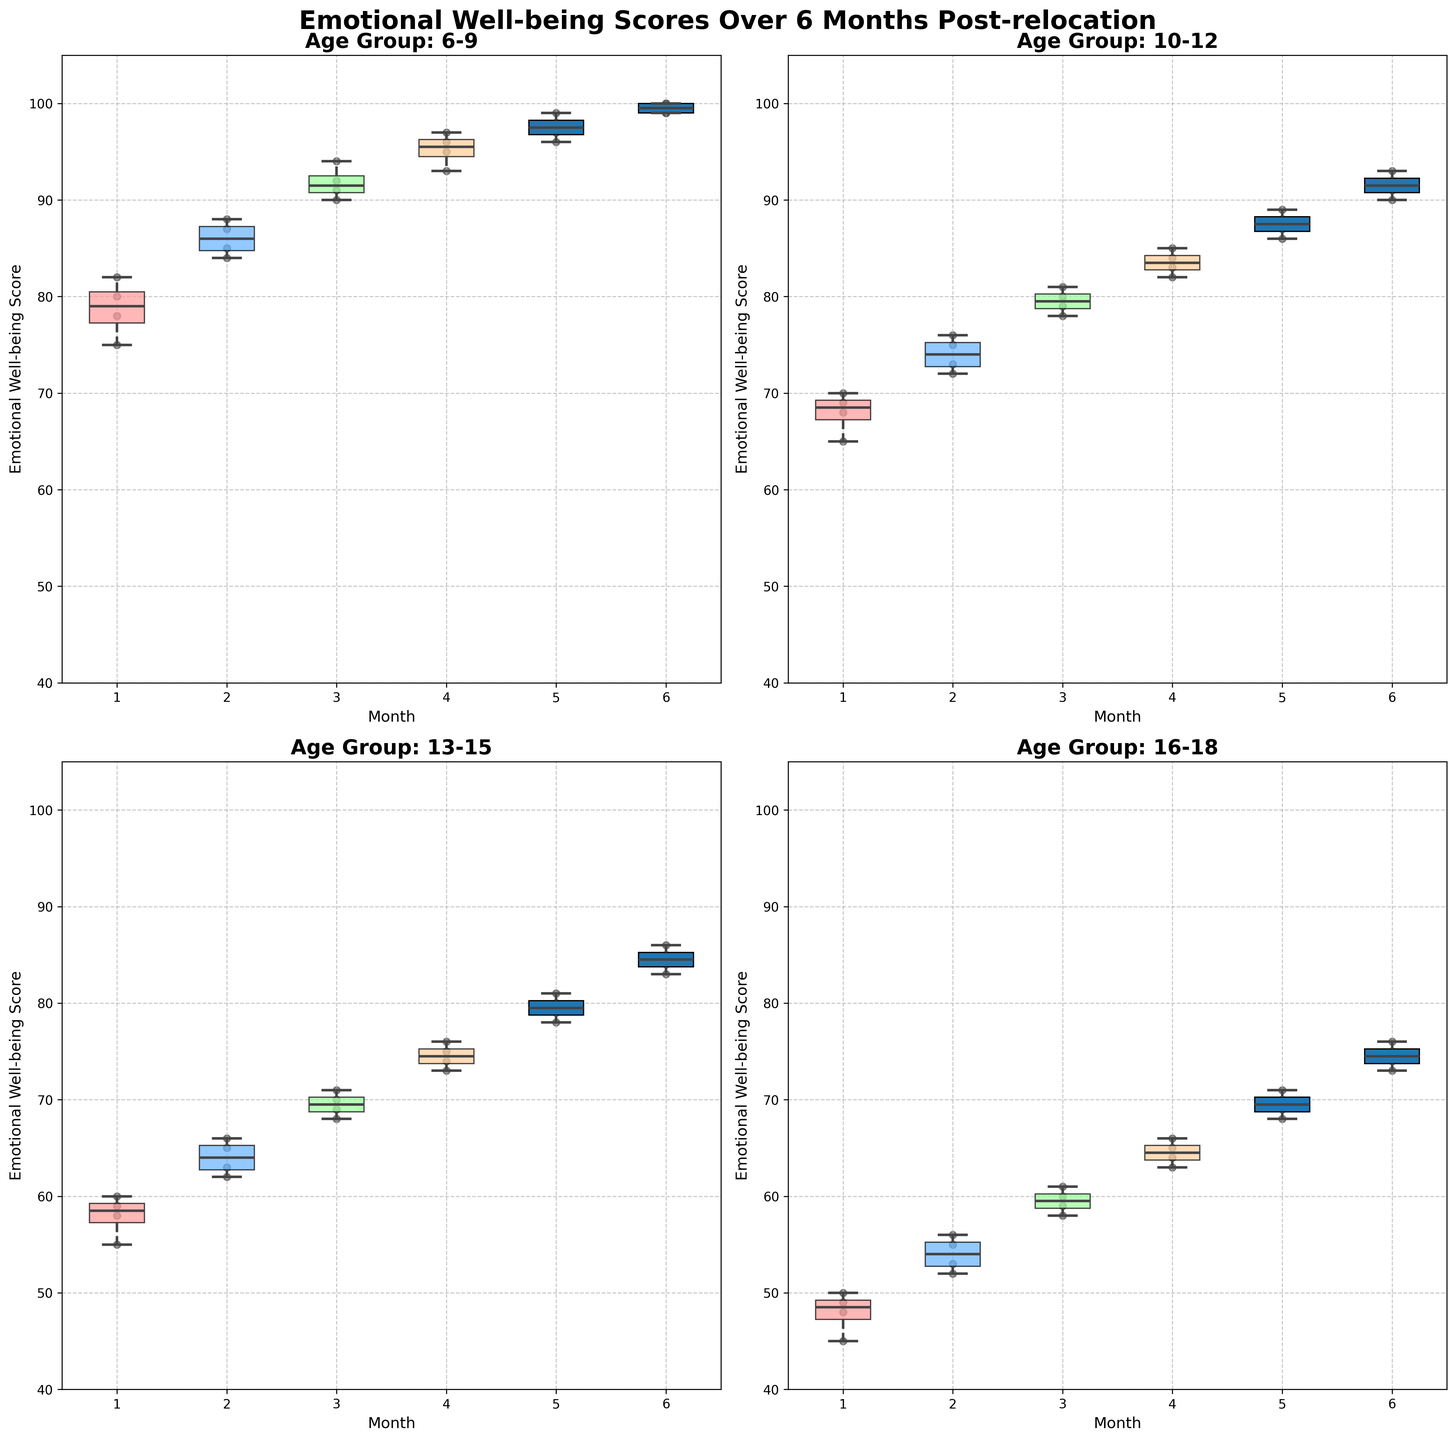How many age groups are displayed in the figure? The figure displays box plots for each age group. By looking at the titles of the subplots, we can count the number of unique age groups.
Answer: 4 Which age group shows the highest median emotional well-being score in the sixth month? To find the highest median value in the sixth month, we need to look at the middle line inside each box plot for each age group's sixth month data. The 6-9 age group has the highest position of the median line, indicating the highest median score.
Answer: 6-9 How does the range of emotional well-being scores change over time for the 10-12 age group? We can observe the box plots for the 10-12 age group across the six months. The range can be seen between the top and bottom lines (whiskers) of each box plot. Initially, the range is wider and narrows down slightly as the months progress.
Answer: Decreases slightly Which age group has the lowest emotional well-being scores in the first month? By checking the lowest points in the first month box plots for each age group, we can determine which group has the lowest scores. The 16-18 age group has the lowest minimum point in the first month.
Answer: 16-18 What is the interquartile range (IQR) for the 13-15 age group's emotional well-being scores in the second month? The IQR can be found by subtracting the lower quartile (bottom of the box) from the upper quartile (top of the box) in the box plot for the second month for the 13-15 age group.
Answer: 3 Which age group's emotional well-being scores improve the most over the six months? To see which group improves the most, compare the median lines across the six months for each age group. The 6-9 age group shows the most significant upward trend in median scores over the six months.
Answer: 6-9 Is there any age group that shows an outlier in their scores? The figure shows box plots without outliers (specified to exclude outliers in the code). Hence, none of the age groups display outliers.
Answer: No How do emotional well-being scores for the 16-18 age group compare between the third and fourth months? To compare, look at the box plot medians for the 16-18 age group in the third and fourth months. The median in the fourth month is higher than in the third month.
Answer: Higher in the fourth month What is the median emotional well-being score for the 13-15 age group in the fifth month? Check the position of the median line within the box plot for the fifth month for the 13-15 age group. The line is located at 79.
Answer: 79 